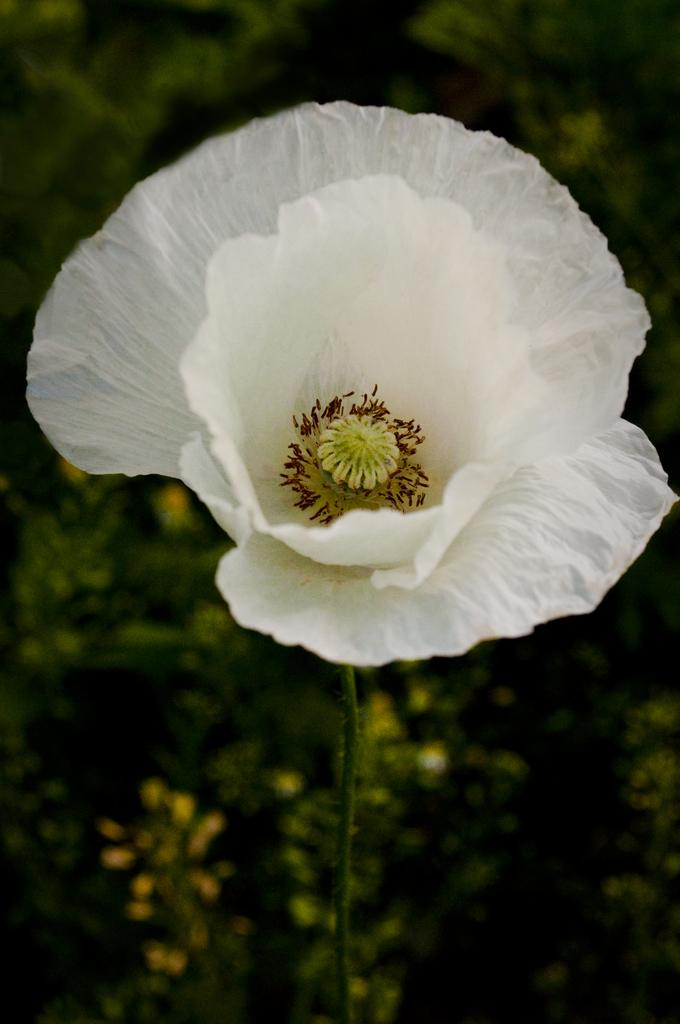What type of flower is in the image? There is a white flower in the image. Can you describe any part of the flower besides its color? The flower has a stem. How would you describe the background of the image? The background is blurred in the image. What can be seen in the blurred background? Greenery is visible in the background. How does the ocean contribute to the knowledge of the flower in the image? There is no ocean or mention of knowledge in the image; it features a white flower with a stem and a blurred background with greenery. 